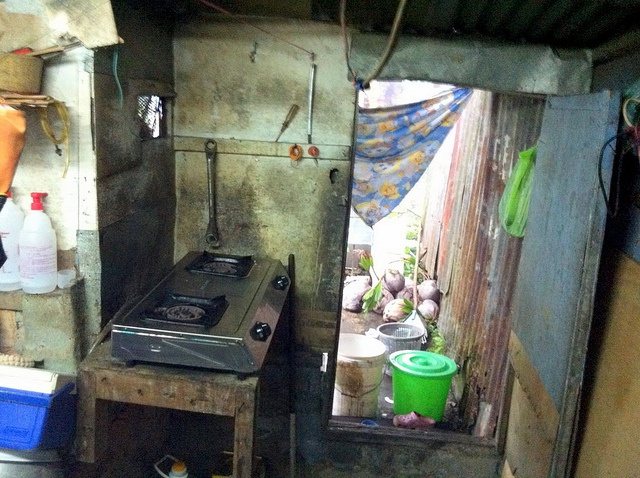Describe the objects in this image and their specific colors. I can see bench in gray and black tones, bottle in gray, lightgray, darkgray, and salmon tones, bottle in gray, lightgray, lightblue, darkgray, and black tones, and bowl in gray, tan, and olive tones in this image. 